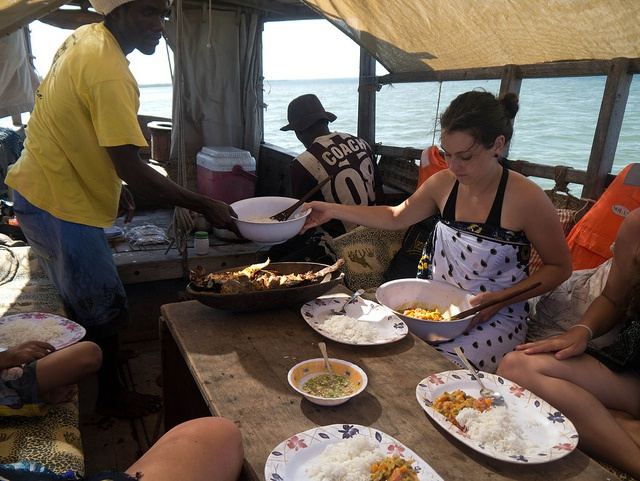Describe the objects in this image and their specific colors. I can see dining table in tan, black, gray, and lightgray tones, people in tan, black, and olive tones, people in tan, black, gray, maroon, and brown tones, people in tan, black, maroon, and brown tones, and people in tan, black, and gray tones in this image. 